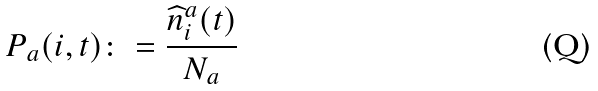<formula> <loc_0><loc_0><loc_500><loc_500>P _ { a } ( i , t ) \colon = \frac { \widehat { n } _ { i } ^ { a } ( t ) } { N _ { a } }</formula> 